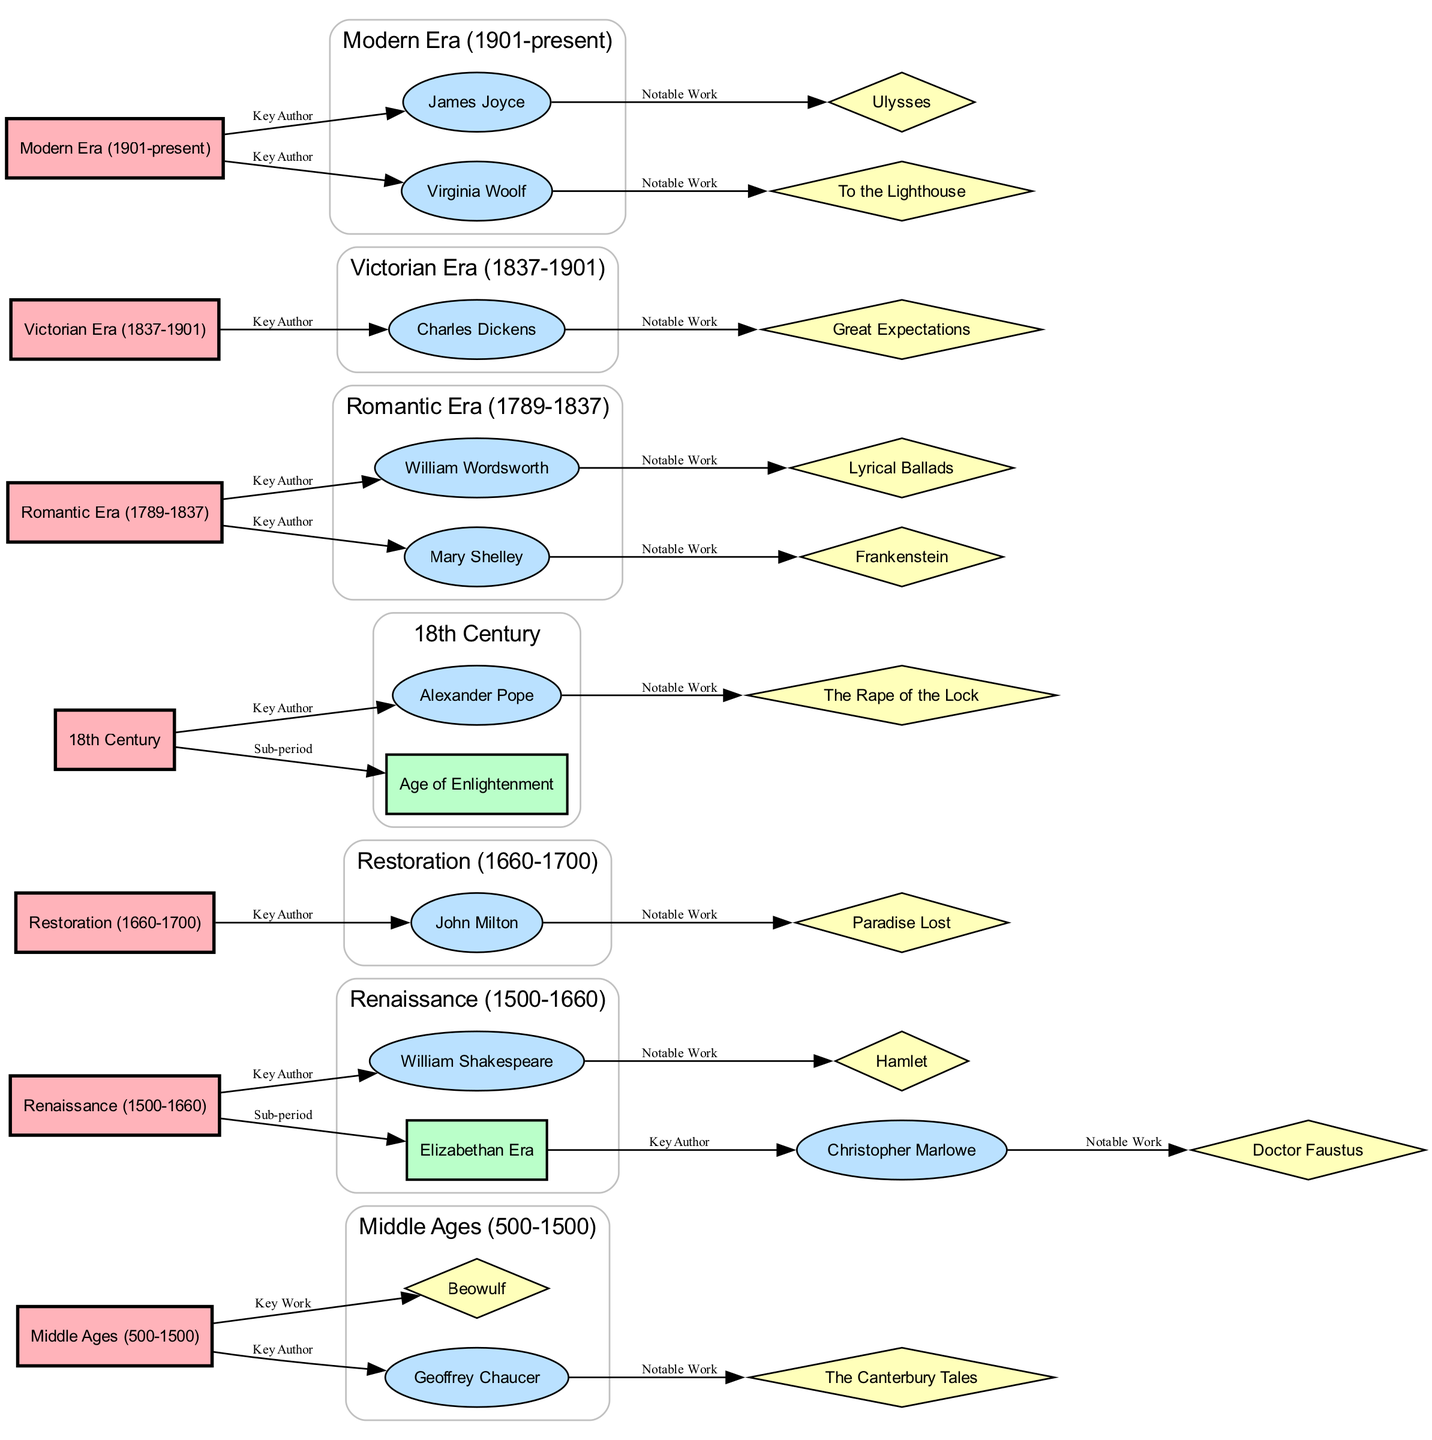What is the time span of the Middle Ages period? The Middle Ages period is labeled as lasting from 500 to 1500. Therefore, I can directly refer to the time span mentioned in the period node.
Answer: 500-1500 Who is the key author associated with the Renaissance? The diagram shows a connection from the Renaissance period node to the William Shakespeare author node, indicating that he is regarded as a key author of this period.
Answer: William Shakespeare How many key authors are linked to the Victorian Era? I can count the edges connecting from the Victorian Era period node; there is a single edge leading to Charles Dickens, indicating he is the key author linked to this era.
Answer: 1 What notable work is associated with Mary Shelley? The edge leading from Mary Shelley to the work node shows a connection labeled "Notable Work," specifically directing me to the title "Frankenstein."
Answer: Frankenstein Which era includes the key work "Great Expectations"? The diagram indicates a connection between the Victorian Era period and the work node for Great Expectations, which informs me that this work is part of the Victorian Era.
Answer: Victorian Era Which two authors are associated with notable works during the Romantic Era? Examining the Romantic Era node reveals two edges that connect to authors: William Wordsworth and Mary Shelley. The diagram leads me to "Lyrical Ballads" and "Frankenstein," respectively, reflecting their notable works.
Answer: William Wordsworth and Mary Shelley Which two periods does the author John Milton belong to? The diagram shows that John Milton is connected to the Restoration period and leads directly to his notable work "Paradise Lost." Hence, both of these relationships help identify the correct period.
Answer: Restoration What is the sub-period of the Renaissance? Referring to the Renaissance node, there is a direct edge that connects to a sub-period labeled "Elizabethan Era." This reveals the sub-period under which the Renaissance is categorized.
Answer: Elizabethan Era How many notable works are associated with the Modern Era? The Modern Era is linked to two authors: James Joyce and Virginia Woolf, each associated with a notable work (Ulysses and To the Lighthouse, respectively). Therefore, I count these edges to find the number of notable works.
Answer: 2 